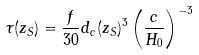<formula> <loc_0><loc_0><loc_500><loc_500>\tau ( z _ { S } ) = \frac { f } { 3 0 } d _ { c } ( z _ { S } ) ^ { 3 } \left ( \frac { c } { H _ { 0 } } \right ) ^ { - 3 }</formula> 